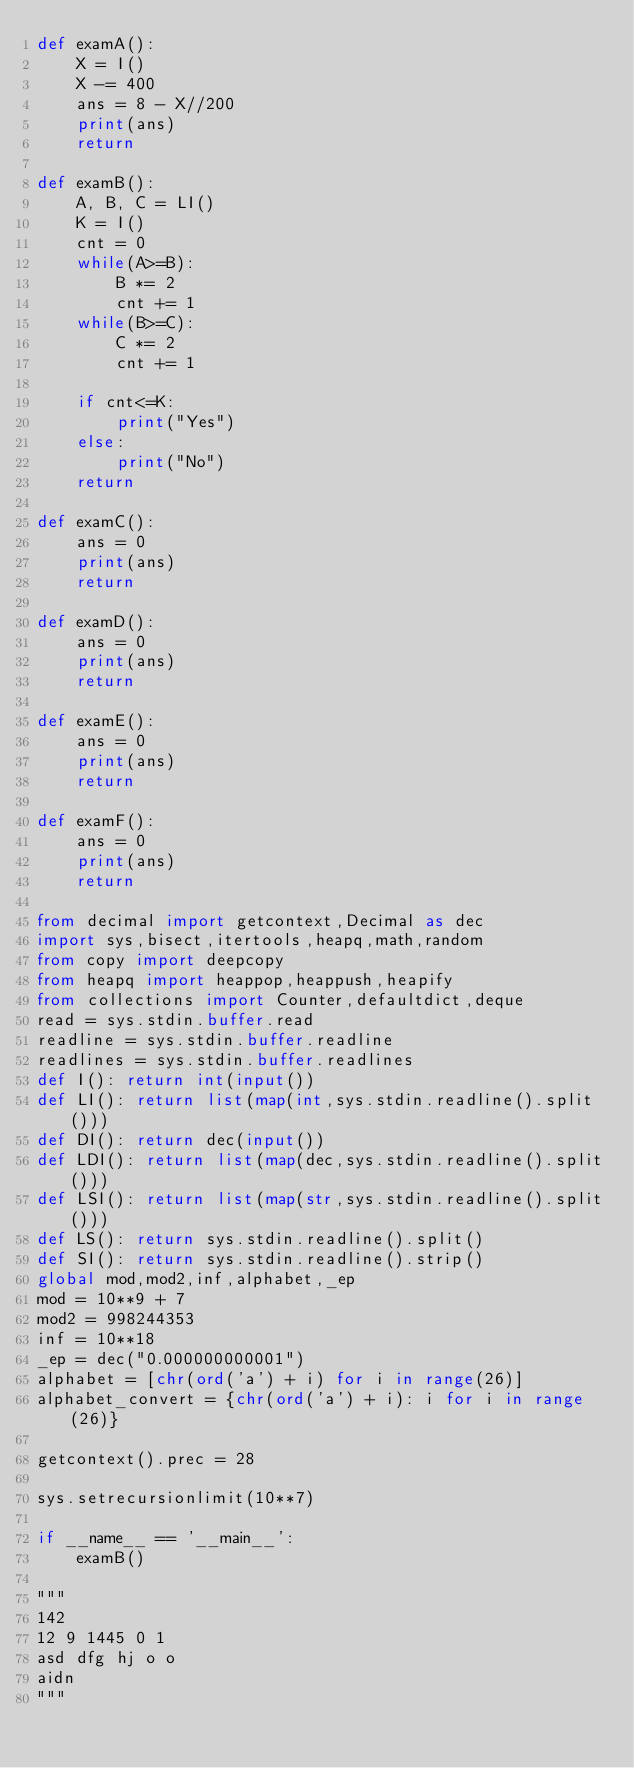<code> <loc_0><loc_0><loc_500><loc_500><_Python_>def examA():
    X = I()
    X -= 400
    ans = 8 - X//200
    print(ans)
    return

def examB():
    A, B, C = LI()
    K = I()
    cnt = 0
    while(A>=B):
        B *= 2
        cnt += 1
    while(B>=C):
        C *= 2
        cnt += 1

    if cnt<=K:
        print("Yes")
    else:
        print("No")
    return

def examC():
    ans = 0
    print(ans)
    return

def examD():
    ans = 0
    print(ans)
    return

def examE():
    ans = 0
    print(ans)
    return

def examF():
    ans = 0
    print(ans)
    return

from decimal import getcontext,Decimal as dec
import sys,bisect,itertools,heapq,math,random
from copy import deepcopy
from heapq import heappop,heappush,heapify
from collections import Counter,defaultdict,deque
read = sys.stdin.buffer.read
readline = sys.stdin.buffer.readline
readlines = sys.stdin.buffer.readlines
def I(): return int(input())
def LI(): return list(map(int,sys.stdin.readline().split()))
def DI(): return dec(input())
def LDI(): return list(map(dec,sys.stdin.readline().split()))
def LSI(): return list(map(str,sys.stdin.readline().split()))
def LS(): return sys.stdin.readline().split()
def SI(): return sys.stdin.readline().strip()
global mod,mod2,inf,alphabet,_ep
mod = 10**9 + 7
mod2 = 998244353
inf = 10**18
_ep = dec("0.000000000001")
alphabet = [chr(ord('a') + i) for i in range(26)]
alphabet_convert = {chr(ord('a') + i): i for i in range(26)}

getcontext().prec = 28

sys.setrecursionlimit(10**7)

if __name__ == '__main__':
    examB()

"""
142
12 9 1445 0 1
asd dfg hj o o
aidn
"""</code> 